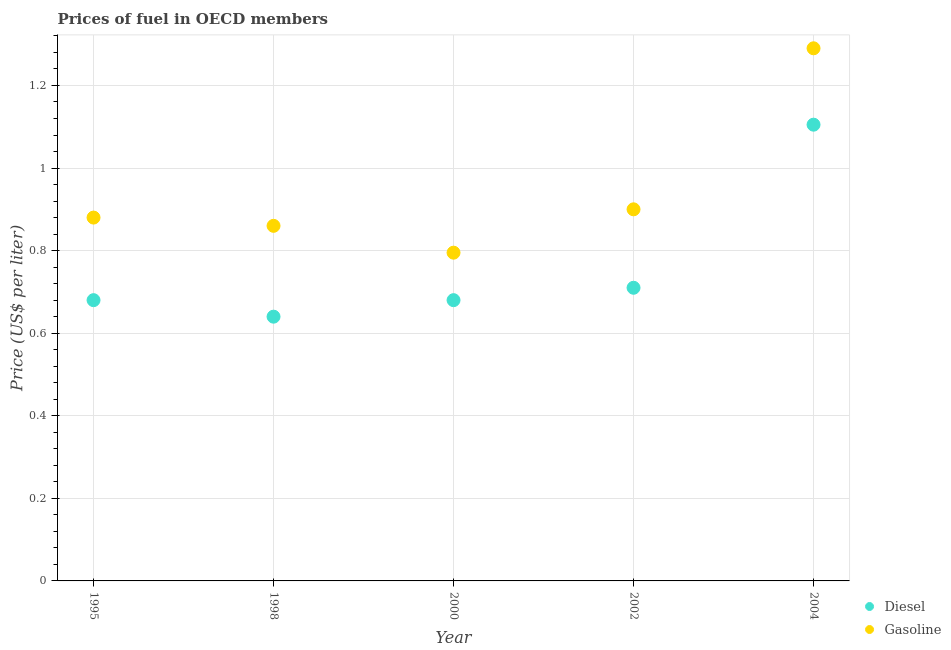How many different coloured dotlines are there?
Your answer should be compact. 2. What is the diesel price in 2000?
Provide a succinct answer. 0.68. Across all years, what is the maximum diesel price?
Your answer should be very brief. 1.1. Across all years, what is the minimum gasoline price?
Your response must be concise. 0.8. In which year was the diesel price maximum?
Your answer should be very brief. 2004. In which year was the gasoline price minimum?
Keep it short and to the point. 2000. What is the total diesel price in the graph?
Ensure brevity in your answer.  3.81. What is the difference between the gasoline price in 1995 and that in 1998?
Your response must be concise. 0.02. What is the difference between the gasoline price in 2002 and the diesel price in 1995?
Keep it short and to the point. 0.22. What is the average diesel price per year?
Offer a very short reply. 0.76. In the year 1998, what is the difference between the diesel price and gasoline price?
Your answer should be very brief. -0.22. What is the ratio of the gasoline price in 1995 to that in 1998?
Your response must be concise. 1.02. Is the difference between the diesel price in 1998 and 2004 greater than the difference between the gasoline price in 1998 and 2004?
Your answer should be very brief. No. What is the difference between the highest and the second highest diesel price?
Ensure brevity in your answer.  0.4. What is the difference between the highest and the lowest gasoline price?
Keep it short and to the point. 0.49. In how many years, is the diesel price greater than the average diesel price taken over all years?
Provide a short and direct response. 1. Is the diesel price strictly greater than the gasoline price over the years?
Make the answer very short. No. How many dotlines are there?
Give a very brief answer. 2. How many years are there in the graph?
Your response must be concise. 5. What is the difference between two consecutive major ticks on the Y-axis?
Make the answer very short. 0.2. Does the graph contain any zero values?
Offer a terse response. No. Does the graph contain grids?
Provide a succinct answer. Yes. Where does the legend appear in the graph?
Your answer should be compact. Bottom right. How many legend labels are there?
Provide a succinct answer. 2. How are the legend labels stacked?
Provide a short and direct response. Vertical. What is the title of the graph?
Keep it short and to the point. Prices of fuel in OECD members. What is the label or title of the Y-axis?
Provide a short and direct response. Price (US$ per liter). What is the Price (US$ per liter) in Diesel in 1995?
Give a very brief answer. 0.68. What is the Price (US$ per liter) of Diesel in 1998?
Give a very brief answer. 0.64. What is the Price (US$ per liter) of Gasoline in 1998?
Provide a short and direct response. 0.86. What is the Price (US$ per liter) of Diesel in 2000?
Offer a very short reply. 0.68. What is the Price (US$ per liter) in Gasoline in 2000?
Keep it short and to the point. 0.8. What is the Price (US$ per liter) of Diesel in 2002?
Keep it short and to the point. 0.71. What is the Price (US$ per liter) of Gasoline in 2002?
Ensure brevity in your answer.  0.9. What is the Price (US$ per liter) of Diesel in 2004?
Keep it short and to the point. 1.1. What is the Price (US$ per liter) of Gasoline in 2004?
Give a very brief answer. 1.29. Across all years, what is the maximum Price (US$ per liter) in Diesel?
Your answer should be compact. 1.1. Across all years, what is the maximum Price (US$ per liter) of Gasoline?
Offer a very short reply. 1.29. Across all years, what is the minimum Price (US$ per liter) of Diesel?
Your answer should be very brief. 0.64. Across all years, what is the minimum Price (US$ per liter) in Gasoline?
Provide a short and direct response. 0.8. What is the total Price (US$ per liter) in Diesel in the graph?
Your response must be concise. 3.81. What is the total Price (US$ per liter) of Gasoline in the graph?
Offer a very short reply. 4.72. What is the difference between the Price (US$ per liter) of Diesel in 1995 and that in 2000?
Give a very brief answer. 0. What is the difference between the Price (US$ per liter) in Gasoline in 1995 and that in 2000?
Your answer should be compact. 0.09. What is the difference between the Price (US$ per liter) of Diesel in 1995 and that in 2002?
Make the answer very short. -0.03. What is the difference between the Price (US$ per liter) of Gasoline in 1995 and that in 2002?
Provide a short and direct response. -0.02. What is the difference between the Price (US$ per liter) of Diesel in 1995 and that in 2004?
Provide a succinct answer. -0.42. What is the difference between the Price (US$ per liter) of Gasoline in 1995 and that in 2004?
Keep it short and to the point. -0.41. What is the difference between the Price (US$ per liter) of Diesel in 1998 and that in 2000?
Your answer should be compact. -0.04. What is the difference between the Price (US$ per liter) of Gasoline in 1998 and that in 2000?
Your answer should be very brief. 0.07. What is the difference between the Price (US$ per liter) in Diesel in 1998 and that in 2002?
Provide a succinct answer. -0.07. What is the difference between the Price (US$ per liter) of Gasoline in 1998 and that in 2002?
Provide a succinct answer. -0.04. What is the difference between the Price (US$ per liter) in Diesel in 1998 and that in 2004?
Give a very brief answer. -0.47. What is the difference between the Price (US$ per liter) in Gasoline in 1998 and that in 2004?
Ensure brevity in your answer.  -0.43. What is the difference between the Price (US$ per liter) of Diesel in 2000 and that in 2002?
Make the answer very short. -0.03. What is the difference between the Price (US$ per liter) in Gasoline in 2000 and that in 2002?
Keep it short and to the point. -0.1. What is the difference between the Price (US$ per liter) in Diesel in 2000 and that in 2004?
Your response must be concise. -0.42. What is the difference between the Price (US$ per liter) of Gasoline in 2000 and that in 2004?
Provide a short and direct response. -0.49. What is the difference between the Price (US$ per liter) of Diesel in 2002 and that in 2004?
Ensure brevity in your answer.  -0.4. What is the difference between the Price (US$ per liter) in Gasoline in 2002 and that in 2004?
Offer a terse response. -0.39. What is the difference between the Price (US$ per liter) of Diesel in 1995 and the Price (US$ per liter) of Gasoline in 1998?
Your answer should be compact. -0.18. What is the difference between the Price (US$ per liter) of Diesel in 1995 and the Price (US$ per liter) of Gasoline in 2000?
Give a very brief answer. -0.12. What is the difference between the Price (US$ per liter) of Diesel in 1995 and the Price (US$ per liter) of Gasoline in 2002?
Your answer should be compact. -0.22. What is the difference between the Price (US$ per liter) in Diesel in 1995 and the Price (US$ per liter) in Gasoline in 2004?
Your response must be concise. -0.61. What is the difference between the Price (US$ per liter) in Diesel in 1998 and the Price (US$ per liter) in Gasoline in 2000?
Offer a very short reply. -0.15. What is the difference between the Price (US$ per liter) of Diesel in 1998 and the Price (US$ per liter) of Gasoline in 2002?
Keep it short and to the point. -0.26. What is the difference between the Price (US$ per liter) in Diesel in 1998 and the Price (US$ per liter) in Gasoline in 2004?
Your answer should be compact. -0.65. What is the difference between the Price (US$ per liter) in Diesel in 2000 and the Price (US$ per liter) in Gasoline in 2002?
Your response must be concise. -0.22. What is the difference between the Price (US$ per liter) of Diesel in 2000 and the Price (US$ per liter) of Gasoline in 2004?
Provide a succinct answer. -0.61. What is the difference between the Price (US$ per liter) in Diesel in 2002 and the Price (US$ per liter) in Gasoline in 2004?
Give a very brief answer. -0.58. What is the average Price (US$ per liter) in Diesel per year?
Offer a very short reply. 0.76. What is the average Price (US$ per liter) in Gasoline per year?
Your answer should be very brief. 0.94. In the year 1995, what is the difference between the Price (US$ per liter) in Diesel and Price (US$ per liter) in Gasoline?
Ensure brevity in your answer.  -0.2. In the year 1998, what is the difference between the Price (US$ per liter) in Diesel and Price (US$ per liter) in Gasoline?
Your response must be concise. -0.22. In the year 2000, what is the difference between the Price (US$ per liter) of Diesel and Price (US$ per liter) of Gasoline?
Offer a very short reply. -0.12. In the year 2002, what is the difference between the Price (US$ per liter) of Diesel and Price (US$ per liter) of Gasoline?
Ensure brevity in your answer.  -0.19. In the year 2004, what is the difference between the Price (US$ per liter) in Diesel and Price (US$ per liter) in Gasoline?
Offer a terse response. -0.18. What is the ratio of the Price (US$ per liter) of Diesel in 1995 to that in 1998?
Provide a succinct answer. 1.06. What is the ratio of the Price (US$ per liter) of Gasoline in 1995 to that in 1998?
Offer a very short reply. 1.02. What is the ratio of the Price (US$ per liter) of Gasoline in 1995 to that in 2000?
Give a very brief answer. 1.11. What is the ratio of the Price (US$ per liter) in Diesel in 1995 to that in 2002?
Your response must be concise. 0.96. What is the ratio of the Price (US$ per liter) in Gasoline in 1995 to that in 2002?
Offer a terse response. 0.98. What is the ratio of the Price (US$ per liter) in Diesel in 1995 to that in 2004?
Provide a succinct answer. 0.62. What is the ratio of the Price (US$ per liter) of Gasoline in 1995 to that in 2004?
Give a very brief answer. 0.68. What is the ratio of the Price (US$ per liter) of Diesel in 1998 to that in 2000?
Provide a short and direct response. 0.94. What is the ratio of the Price (US$ per liter) of Gasoline in 1998 to that in 2000?
Give a very brief answer. 1.08. What is the ratio of the Price (US$ per liter) in Diesel in 1998 to that in 2002?
Offer a very short reply. 0.9. What is the ratio of the Price (US$ per liter) of Gasoline in 1998 to that in 2002?
Your response must be concise. 0.96. What is the ratio of the Price (US$ per liter) of Diesel in 1998 to that in 2004?
Keep it short and to the point. 0.58. What is the ratio of the Price (US$ per liter) in Gasoline in 1998 to that in 2004?
Keep it short and to the point. 0.67. What is the ratio of the Price (US$ per liter) of Diesel in 2000 to that in 2002?
Your answer should be compact. 0.96. What is the ratio of the Price (US$ per liter) of Gasoline in 2000 to that in 2002?
Offer a very short reply. 0.88. What is the ratio of the Price (US$ per liter) in Diesel in 2000 to that in 2004?
Your answer should be compact. 0.62. What is the ratio of the Price (US$ per liter) in Gasoline in 2000 to that in 2004?
Your response must be concise. 0.62. What is the ratio of the Price (US$ per liter) of Diesel in 2002 to that in 2004?
Your response must be concise. 0.64. What is the ratio of the Price (US$ per liter) in Gasoline in 2002 to that in 2004?
Keep it short and to the point. 0.7. What is the difference between the highest and the second highest Price (US$ per liter) in Diesel?
Your answer should be very brief. 0.4. What is the difference between the highest and the second highest Price (US$ per liter) in Gasoline?
Your answer should be very brief. 0.39. What is the difference between the highest and the lowest Price (US$ per liter) in Diesel?
Offer a very short reply. 0.47. What is the difference between the highest and the lowest Price (US$ per liter) of Gasoline?
Keep it short and to the point. 0.49. 